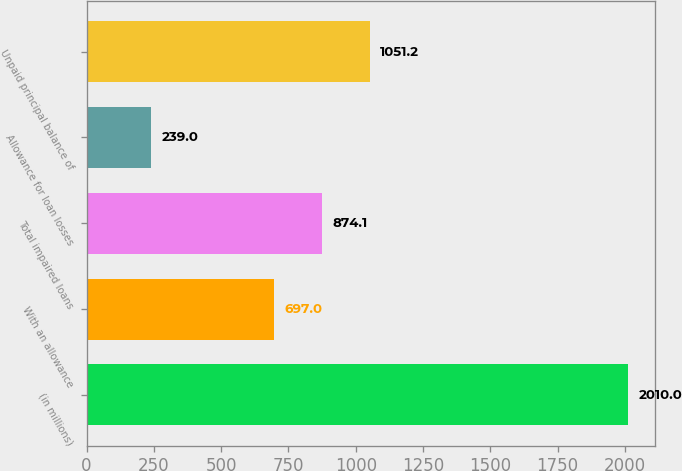Convert chart. <chart><loc_0><loc_0><loc_500><loc_500><bar_chart><fcel>(in millions)<fcel>With an allowance<fcel>Total impaired loans<fcel>Allowance for loan losses<fcel>Unpaid principal balance of<nl><fcel>2010<fcel>697<fcel>874.1<fcel>239<fcel>1051.2<nl></chart> 